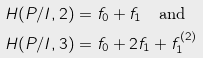Convert formula to latex. <formula><loc_0><loc_0><loc_500><loc_500>H ( P / I , 2 ) & = f _ { 0 } + f _ { 1 } \quad \text {and} \\ H ( P / I , 3 ) & = f _ { 0 } + 2 f _ { 1 } + f _ { 1 } ^ { ( 2 ) }</formula> 